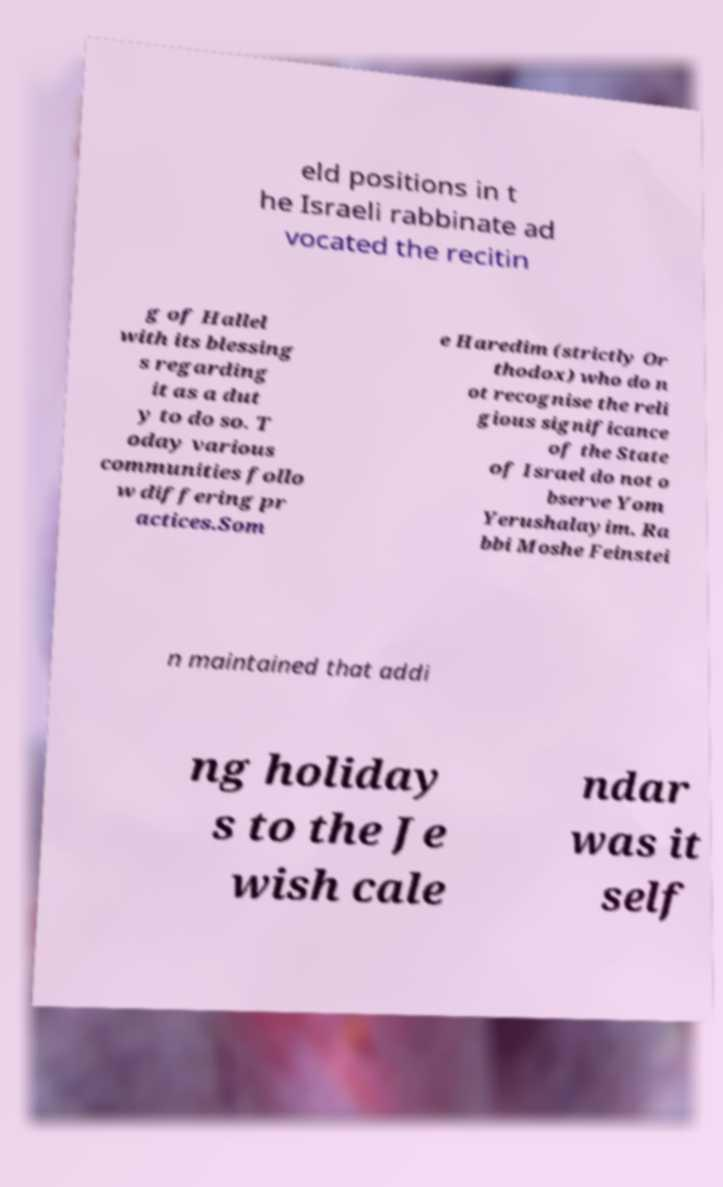Please identify and transcribe the text found in this image. eld positions in t he Israeli rabbinate ad vocated the recitin g of Hallel with its blessing s regarding it as a dut y to do so. T oday various communities follo w differing pr actices.Som e Haredim (strictly Or thodox) who do n ot recognise the reli gious significance of the State of Israel do not o bserve Yom Yerushalayim. Ra bbi Moshe Feinstei n maintained that addi ng holiday s to the Je wish cale ndar was it self 